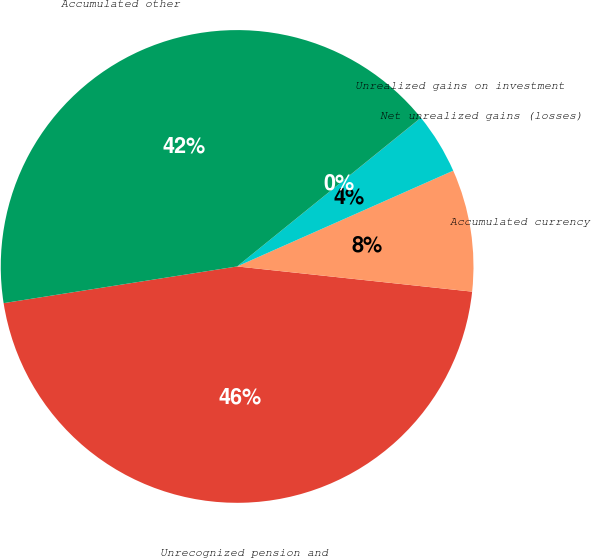Convert chart. <chart><loc_0><loc_0><loc_500><loc_500><pie_chart><fcel>Unrecognized pension and<fcel>Accumulated currency<fcel>Net unrealized gains (losses)<fcel>Unrealized gains on investment<fcel>Accumulated other<nl><fcel>45.82%<fcel>8.34%<fcel>4.18%<fcel>0.01%<fcel>41.65%<nl></chart> 